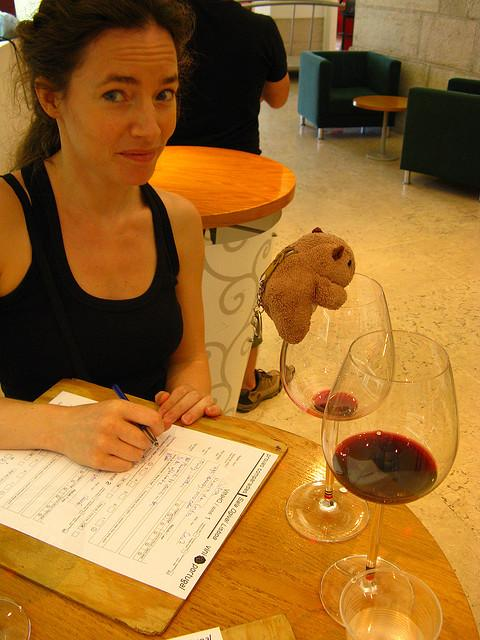What does it look like the stuffed animal is doing?

Choices:
A) eating
B) drinking
C) singing
D) attacking drinking 